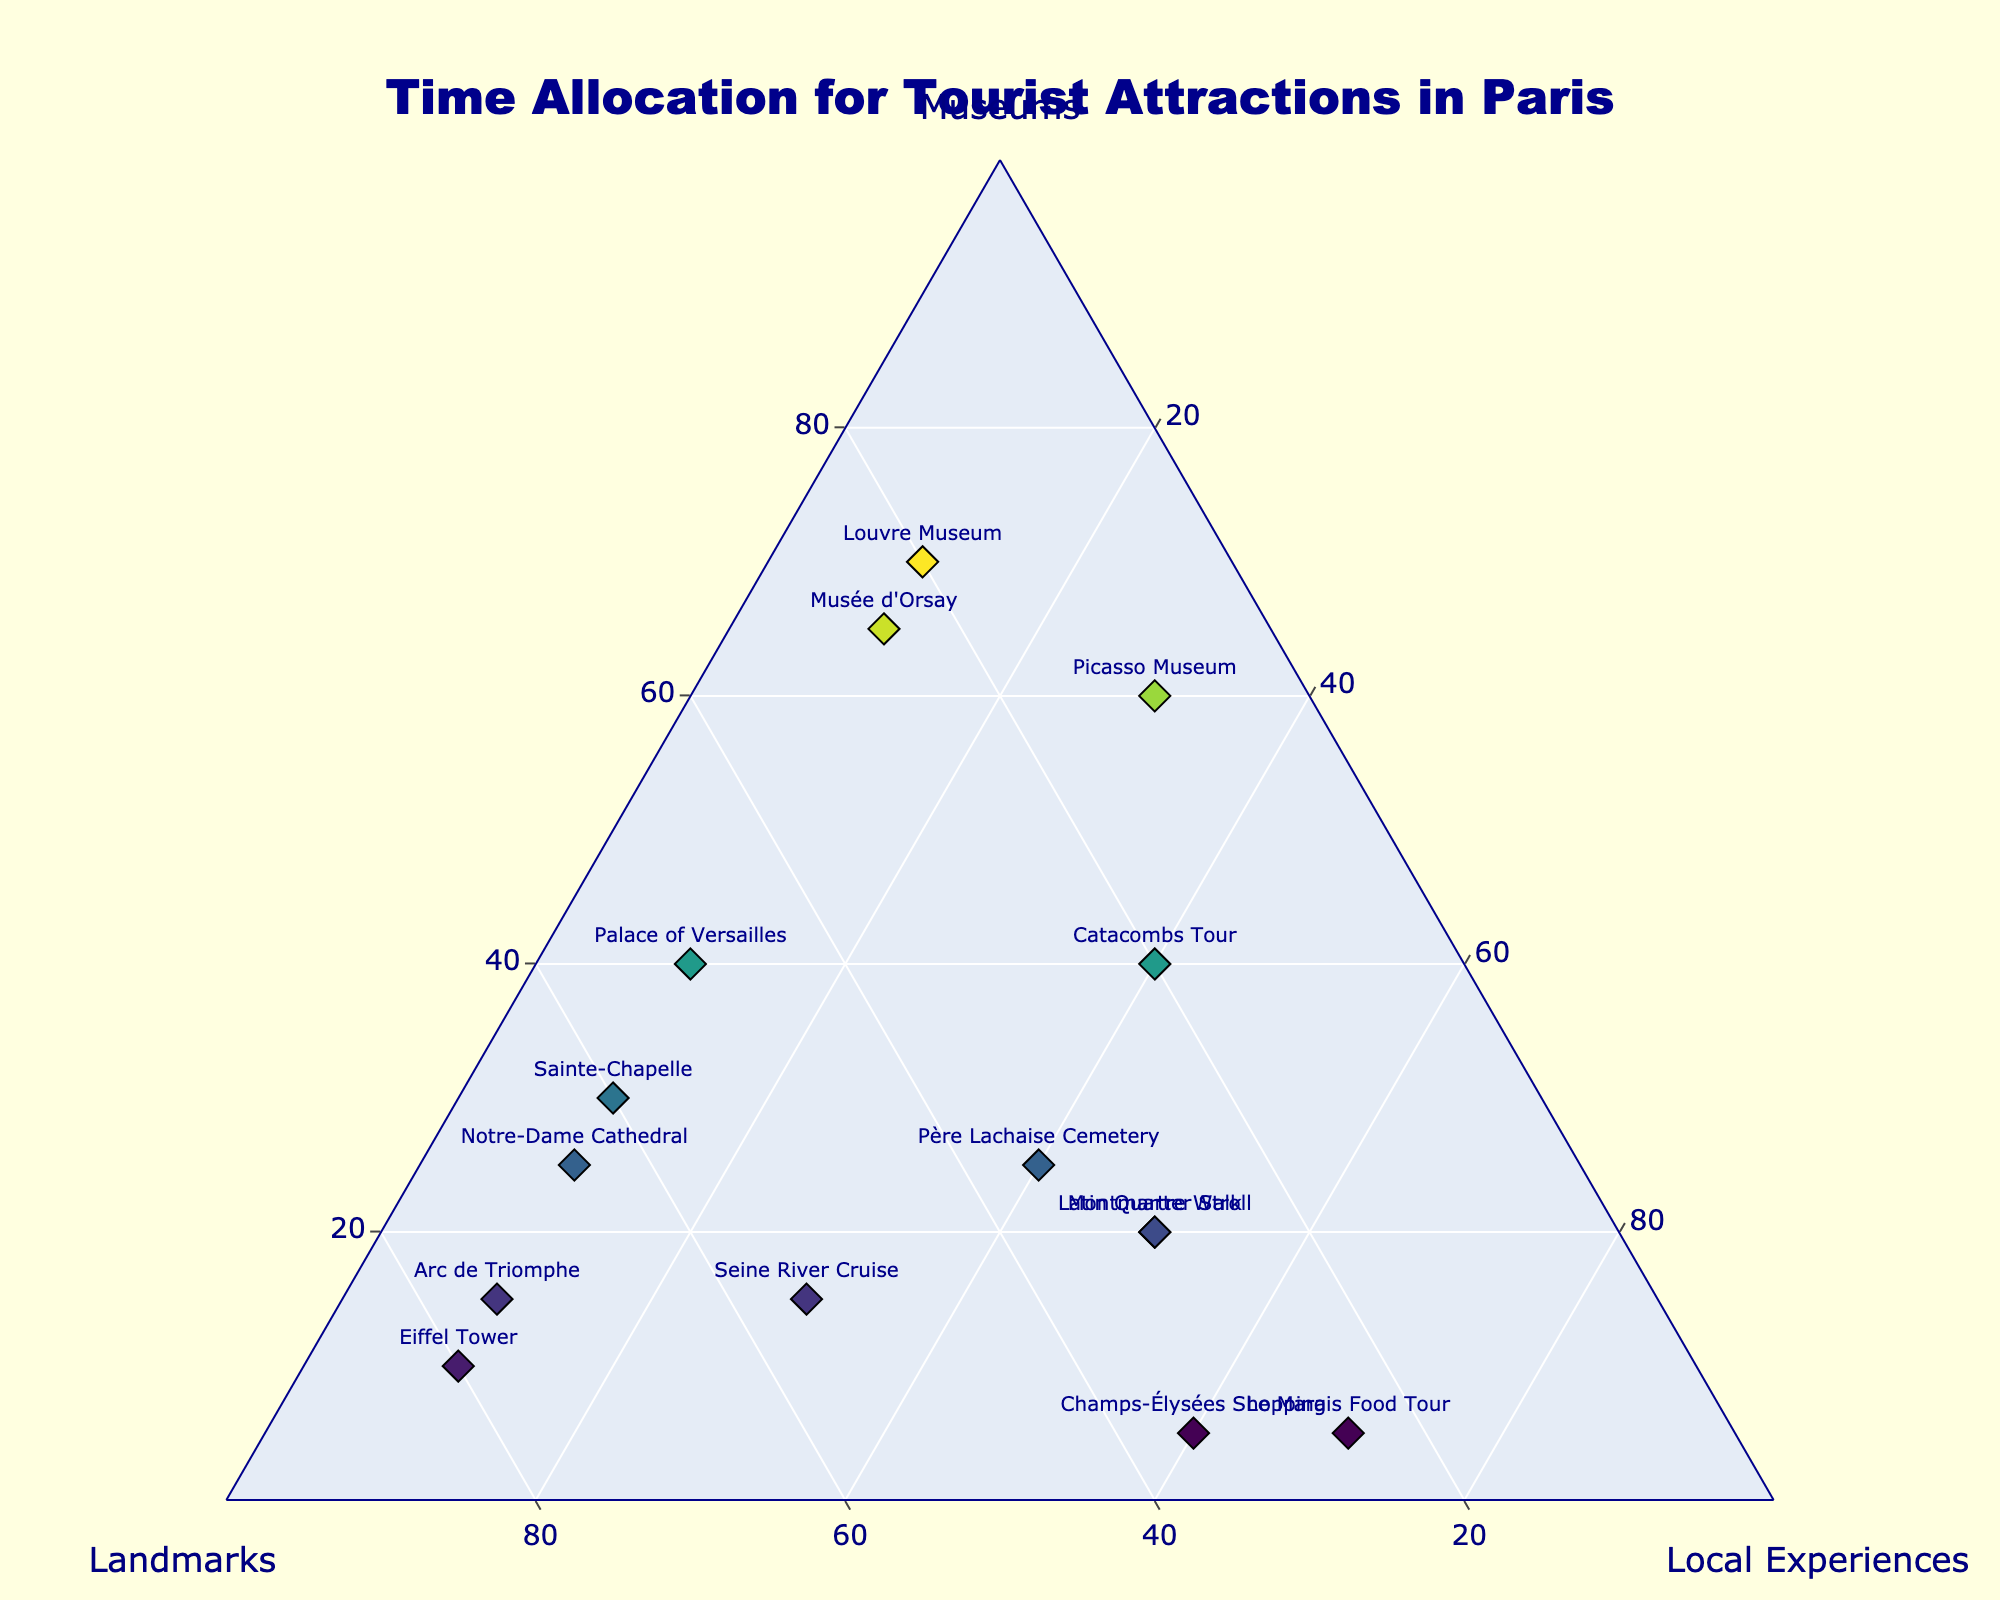What is the title of the figure? The title of the figure is displayed at the top center of the plot. It usually describes the main theme of the figure.
Answer: Time Allocation for Tourist Attractions in Paris Which attraction has the highest allocation for Landmarks? By referring to the markers on the ternary plot, we can see that the Eiffel Tower has the highest allocation for Landmarks at 80%.
Answer: Eiffel Tower What is the average percentage of time spent in Museums for all attractions? We sum up all the percentages of time spent in Museums for all listed attractions and then divide by the number of attractions: (70+10+20+15+25+40+5+65+15+20+30+25+60+5+40)/15 = 445/15 ≈ 29.67%.
Answer: 29.67% Which attractions allocate equal time to Local Experiences? By examining the markers and their corresponding percentages on the plot, we identify Louvre Museum, Eiffel Tower, Notre-Dame Cathedral, Musée d'Orsay, Arc de Triomphe, and Sainte-Chapelle each allocate 10% to Local Experiences.
Answer: Louvre Museum, Eiffel Tower, Notre-Dame Cathedral, Musée d'Orsay, Arc de Triomphe, Sainte-Chapelle What’s the total percentage of time allocated to Local Experiences for 'Montmartre Walk' and 'Latin Quarter Stroll'? Both attractions allocate 50% of time to Local Experiences. Adding these gives 50% + 50% = 100%.
Answer: 100% How many attractions allocate more than 60% of time to any one type of activity? By noting each data point, the attractions are numbers that allocate more than 60% to either Museums, Landmarks, or Local Experiences: Louvre Museum (Museums 70%), Eiffel Tower (Landmarks 80%), Musée d'Orsay (Museums 65%), Arc de Triomphe (Landmarks 75%), Sainte-Chapelle (Landmarks 60%), and Le Marais Food Tour (Local Experiences 70%). So there are 6 attractions.
Answer: 6 Which attraction has the most balanced allocation of time among Museums, Landmarks, and Local Experiences? By observing the distances of each marker to the vertices, the 'Père Lachaise Cemetery' and 'Catacombs Tour' seem closest to a balanced allocation with 25/35/40 and 40/20/40, respectively. But 'Père Lachaise Cemetery' looks more balanced with smaller differences among the three categories.
Answer: Père Lachaise Cemetery What is the difference in the local experience allocation between 'Le Marais Food Tour' and 'Champs-Élysées Shopping'? Le Marais Food Tour allocates 70%, whereas Champs-Élysées Shopping allocates 60%, leading to a difference of 70% - 60% = 10%.
Answer: 10% 